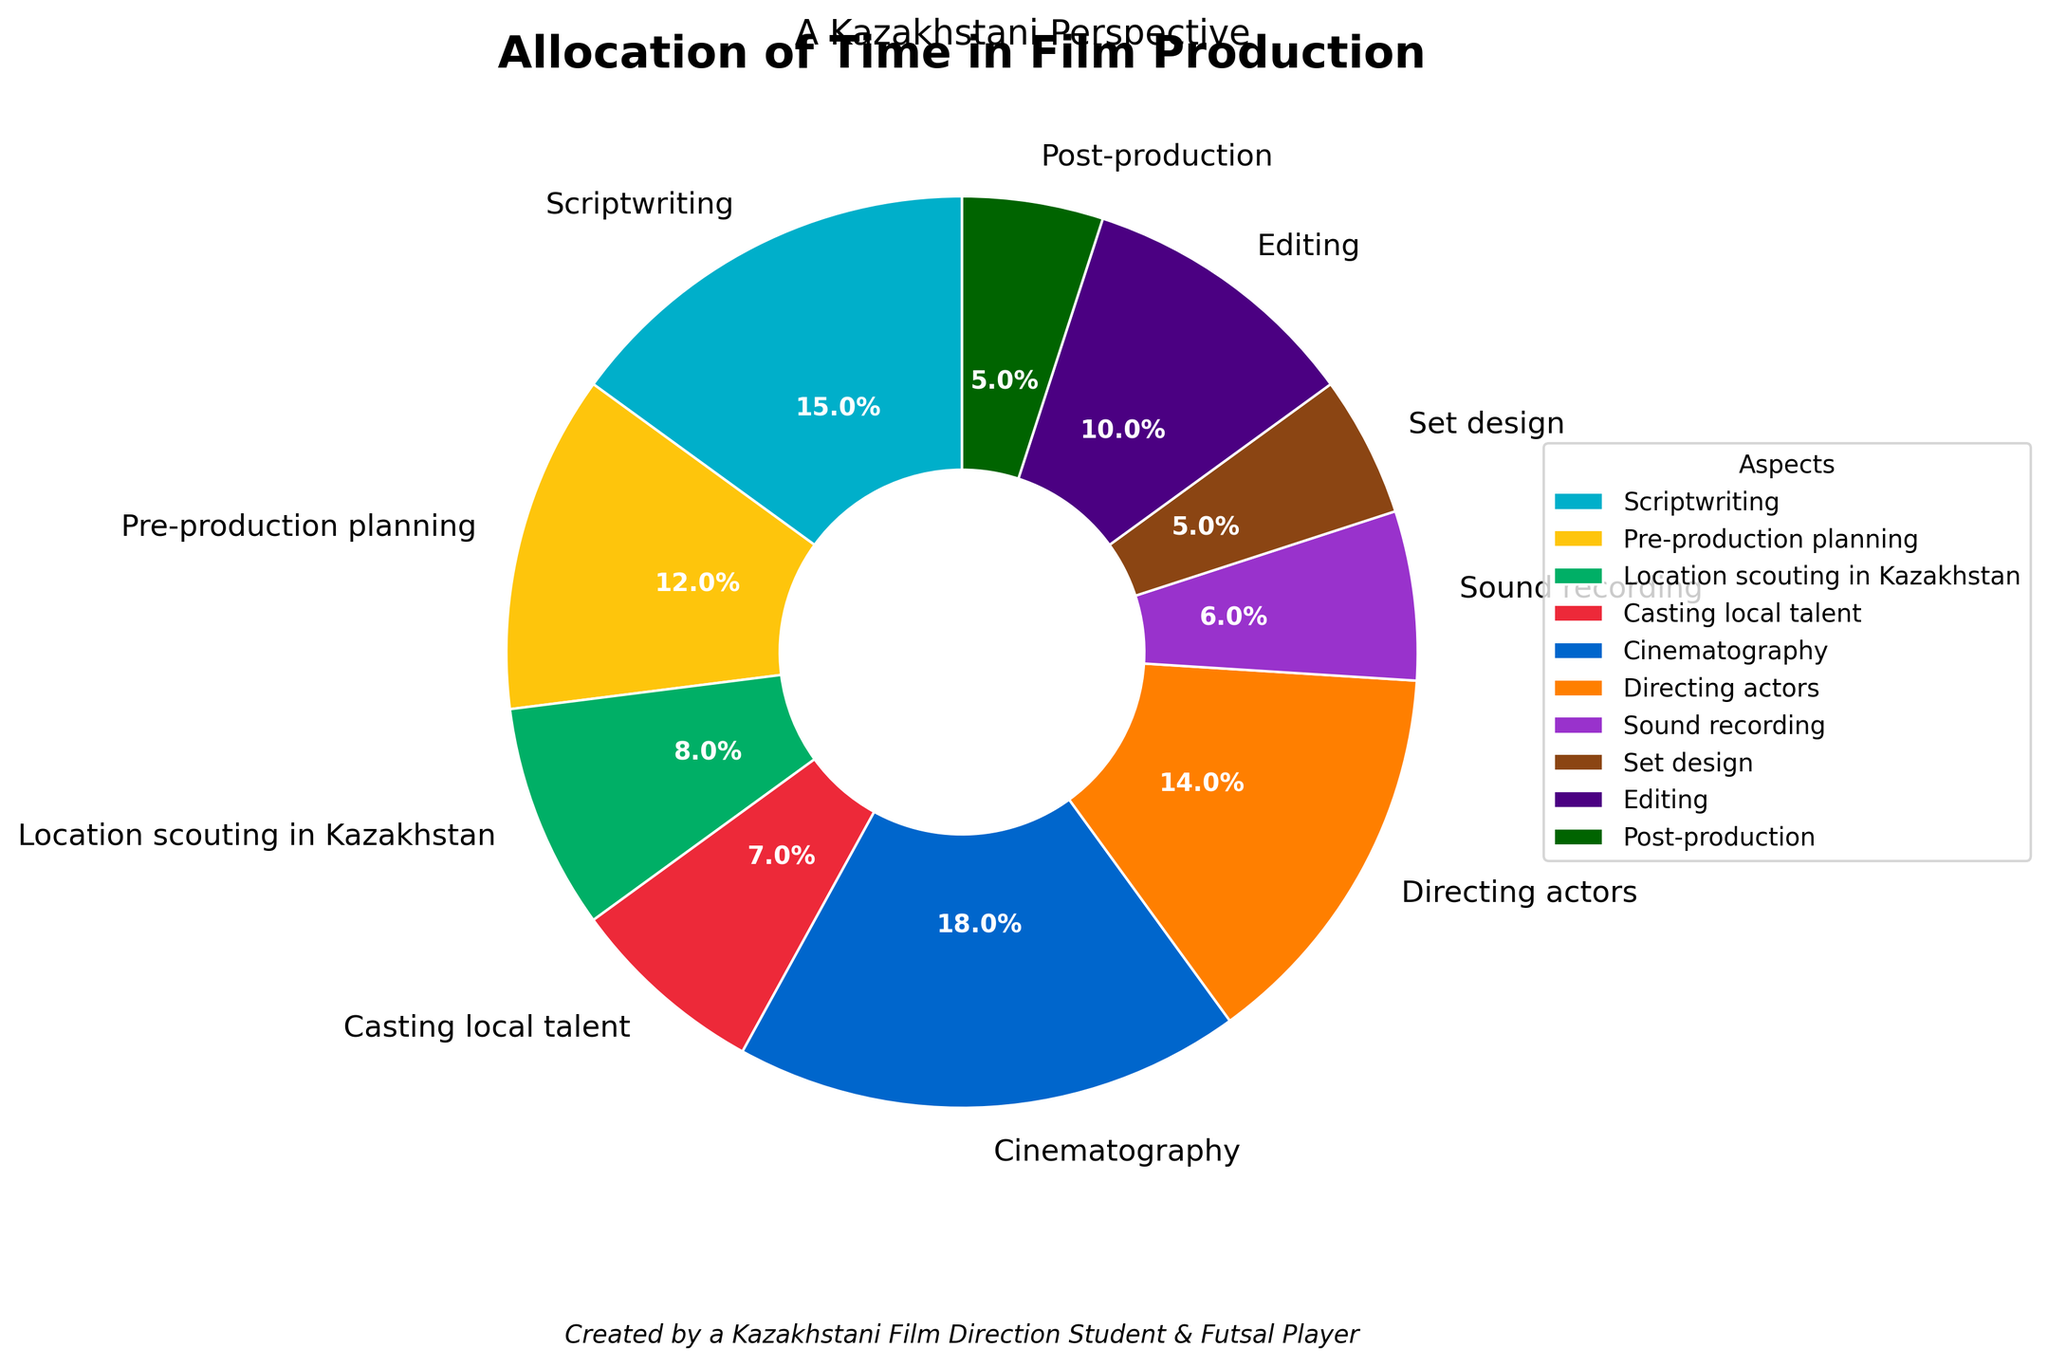what is the largest portion of time spent on? To find the largest portion of time, look at each section's percentages in the pie chart. Identify the segment with the highest percentage.
Answer: Cinematography what's the total time spent on scriptwriting, directing actors, and editing combined? Add the percentages of scriptwriting (15%), directing actors (14%), and editing (10%). The sum is 15 + 14 + 10.
Answer: 39 which aspect takes more time: pre-production planning or location scouting in Kazakhstan? Compare the percentages of pre-production planning (12%) and location scouting in Kazakhstan (8%). 12% is greater than 8%.
Answer: Pre-production planning which parts of the process have the same allocation of time? Identify the segments with equal percentages in the pie chart. Both set design and post-production have 5%.
Answer: Set design and post-production is time allocated to sound recording more than casting local talent? Compare the percentages of sound recording (6%) and casting local talent (7%). 6% is less than 7%.
Answer: No if we combine scriptwriting and pre-production planning, will it be more than cinematography? Add the percentages of scriptwriting (15%) and pre-production planning (12%) to get 27%. Compare this to cinematography's 18%.
Answer: Yes which visual aspect makes it easy to identify the different segments? The pie chart uses distinct colors for each segment, making it easy to differentiate between them.
Answer: Colors what percentage of the production time is spent on activities directly involving actors? Sum the percentages for casting local talent (7%) and directing actors (14%). The sum is 7 + 14.
Answer: 21 is the time percentage spent on set design and location scouting in Kazakhstan equal to the time spent on editing? Add the percentages for set design (5%) and location scouting (8%), which sum up to 13%. Compare this to editing's 10%.
Answer: No 